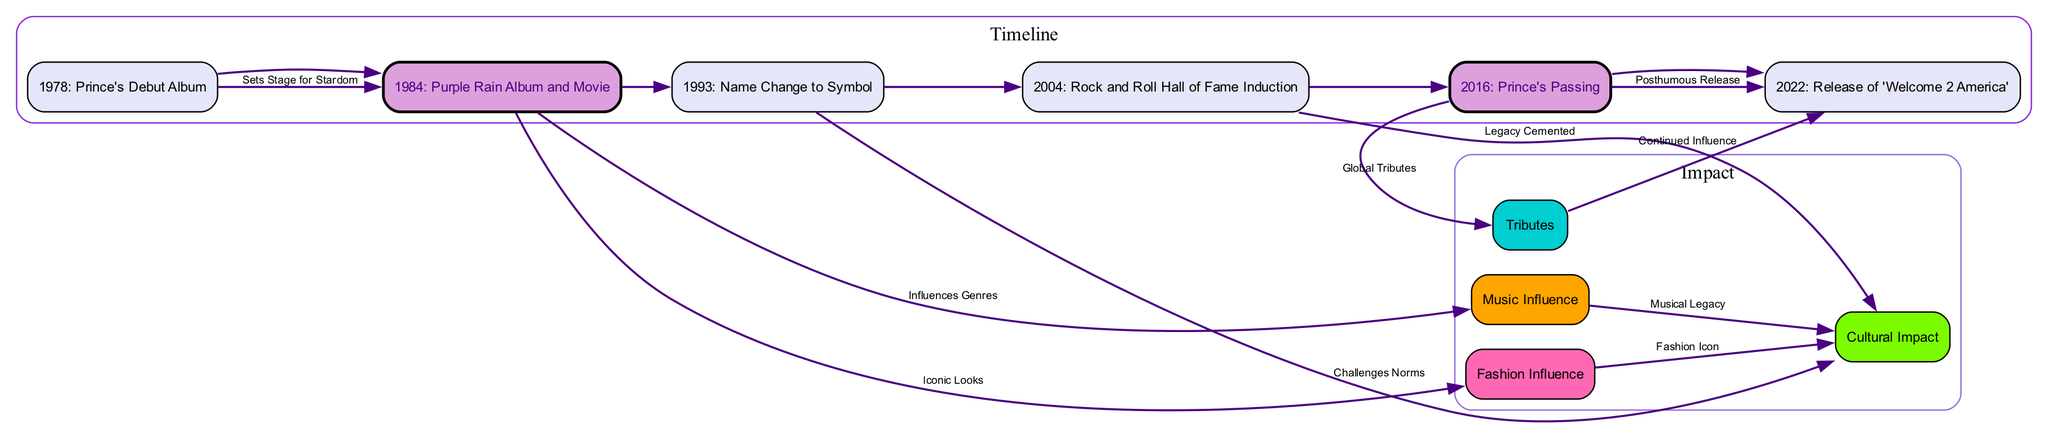What event marks Prince's debut in the music industry? The diagram indicates that Prince's debut in the music industry is marked by "1978: Prince's Debut Album" as one of the nodes.
Answer: 1978: Prince's Debut Album What significant release occurred in 1984? The diagram highlights "1984: Purple Rain Album and Movie" as a key event, showing a direct connection from this node.
Answer: Purple Rain Album and Movie How many edges connect the "Purple Rain Album and Movie" to other nodes? By counting the edges extending from "1984: Purple Rain Album and Movie," we find there are 2 direct connections leading to "Prince's Influence on Music" and "Prince's Fashion Influence."
Answer: 2 What was the outcome of Prince's passing in 2016? The diagram illustrates that following Prince's passing in 2016 (Node 5), there are connections to both "Global Tributes" and "Posthumous Release," indicating the impact he had even after his death.
Answer: Global Tributes and Posthumous Release What relationship does the "Name Change to Symbol" have with cultural impact? According to the diagram, "1993: Name Change to Symbol" has a connection labeled "Challenges Norms" directed towards "Prince's Cultural Impact," showing that the name change influenced cultural discussions and norms.
Answer: Challenges Norms Which event solidified Prince's legacy in the music industry? The diagram points to "2004: Rock and Roll Hall of Fame Induction" as the event that solidified his legacy, connecting it to "Prince's Cultural Impact."
Answer: Rock and Roll Hall of Fame Induction How does Prince's fashion influence relate to his cultural impact? The diagram details that "Prince's Fashion Influence" leads to "Prince's Cultural Impact," indicating that his fashion choices contributed significantly to his overall cultural significance.
Answer: Fashion Icon What is the latest event depicted in the diagram? The last node seen in the diagram is "2022: Release of 'Welcome 2 America,'" demonstrating a continued influence of Prince's work in recent years.
Answer: Release of 'Welcome 2 America' 